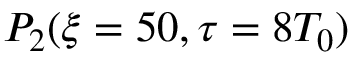<formula> <loc_0><loc_0><loc_500><loc_500>P _ { 2 } ( \xi = 5 0 , \tau = 8 T _ { 0 } )</formula> 